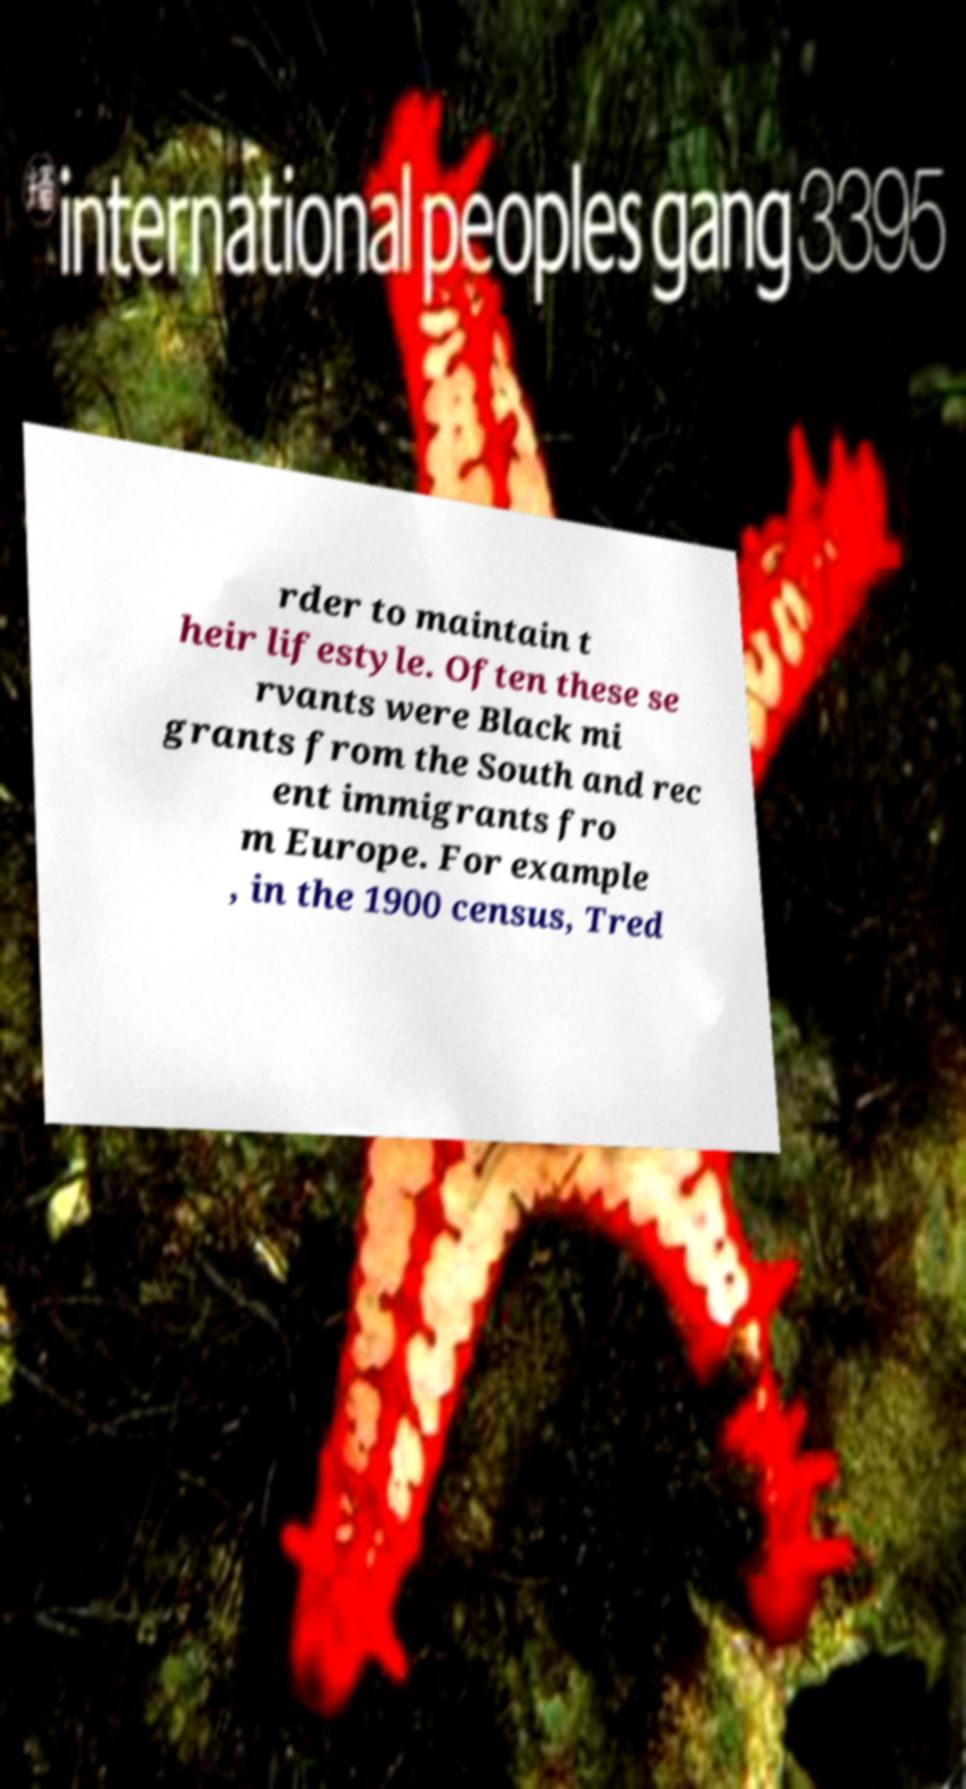What messages or text are displayed in this image? I need them in a readable, typed format. rder to maintain t heir lifestyle. Often these se rvants were Black mi grants from the South and rec ent immigrants fro m Europe. For example , in the 1900 census, Tred 